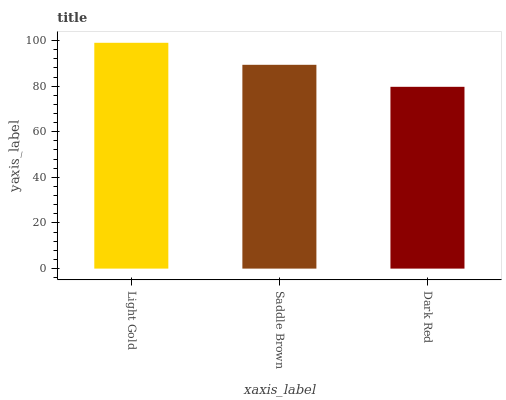Is Dark Red the minimum?
Answer yes or no. Yes. Is Light Gold the maximum?
Answer yes or no. Yes. Is Saddle Brown the minimum?
Answer yes or no. No. Is Saddle Brown the maximum?
Answer yes or no. No. Is Light Gold greater than Saddle Brown?
Answer yes or no. Yes. Is Saddle Brown less than Light Gold?
Answer yes or no. Yes. Is Saddle Brown greater than Light Gold?
Answer yes or no. No. Is Light Gold less than Saddle Brown?
Answer yes or no. No. Is Saddle Brown the high median?
Answer yes or no. Yes. Is Saddle Brown the low median?
Answer yes or no. Yes. Is Light Gold the high median?
Answer yes or no. No. Is Light Gold the low median?
Answer yes or no. No. 